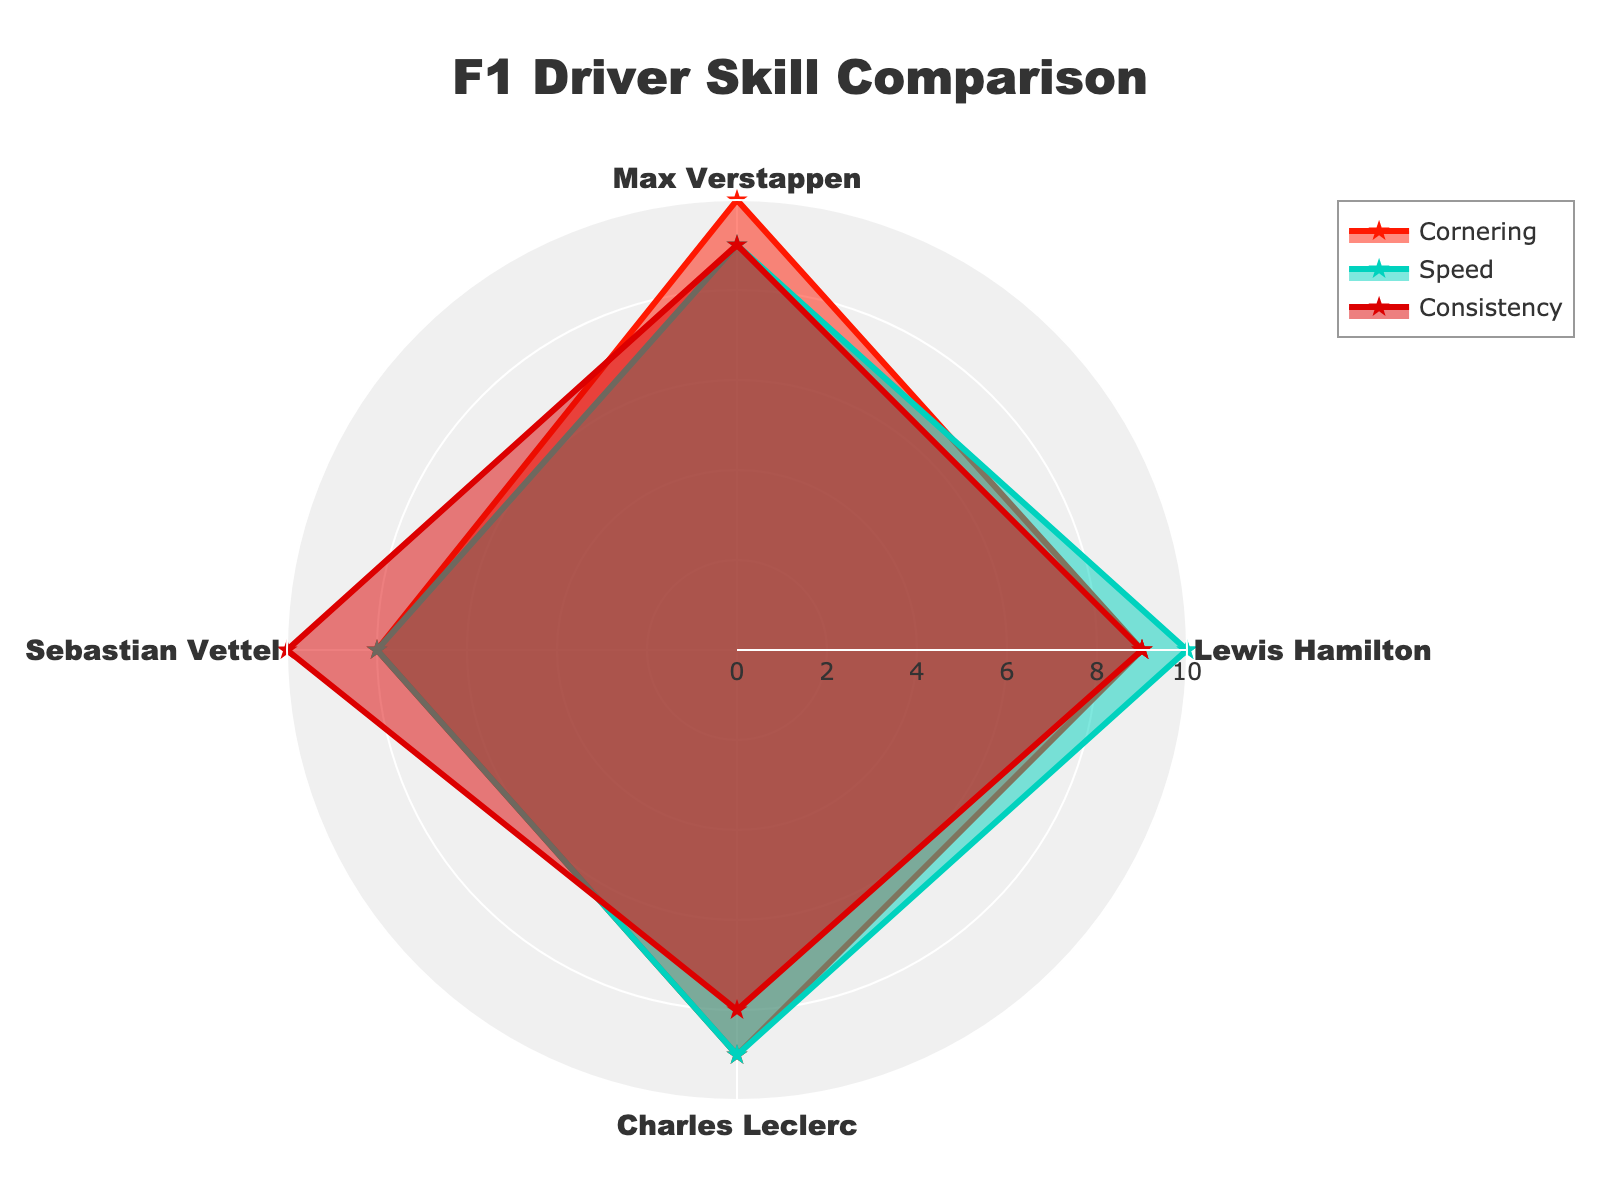what is the title of the figure? The title of the figure can be found at the top of the chart. It provides a brief description of the visualized data.
Answer: F1 Driver Skill Comparison what are the categories being compared in the radar chart? The categories being compared in the radar chart are labeled along the radial axis of the chart and represent the different racing techniques. By looking at the axis labels, one can identify these categories.
Answer: Cornering, Speed, Consistency which driver has the highest speed rating? Locate the 'Speed' axis on the radar chart and compare the ratings of each driver along this axis. The driver with the highest score on this axis has the highest speed rating.
Answer: Lewis Hamilton what is the average cornering score of all drivers? Add up the cornering scores of all drivers and divide by the number of drivers. The scores are Lewis (9), Max (10), Sebastian (8), and Charles (9). Sum = 36. Average = 36/4 = 9
Answer: 9 which driver has the lowest consistency rating? Look at the 'Consistency' axis, identify each driver's rating, and find the one with the lowest score.
Answer: Charles Leclerc compare the cornering and speed ratings for Max Verstappen Check Max Verstappen's ratings for both cornering and speed on their respective axes in the radar chart. The ratings are marked, compare the values visually.
Answer: Cornering: 10, Speed: 9 which driver has the most balanced skill set across all techniques? To determine the most balanced skill set, look for a driver whose ratings are closest to each other across all three categories. Check the radar chart where the plot appears most evenly distributed.
Answer: Max Verstappen what's the difference between Sebastian Vettel's speed and consistency ratings? Find Sebastian Vettel's ratings for speed (8) and consistency (10) from the radar chart. The difference can be calculated by subtracting the speed rating from the consistency rating.
Answer: 2 which two drivers have the same consistency rating? Look at the 'Consistency' axis and compare the ratings of all drivers to see which two drivers have identical scores in this category.
Answer: Lewis Hamilton and Max Verstappen rank the drivers based on their cornering scores List the drivers and their cornering scores, then arrange them in descending order. Lewis: 9, Max: 10, Sebastian: 8, Charles: 9
Answer: Max Verstappen, Lewis Hamilton, Charles Leclerc, Sebastian Vettel 